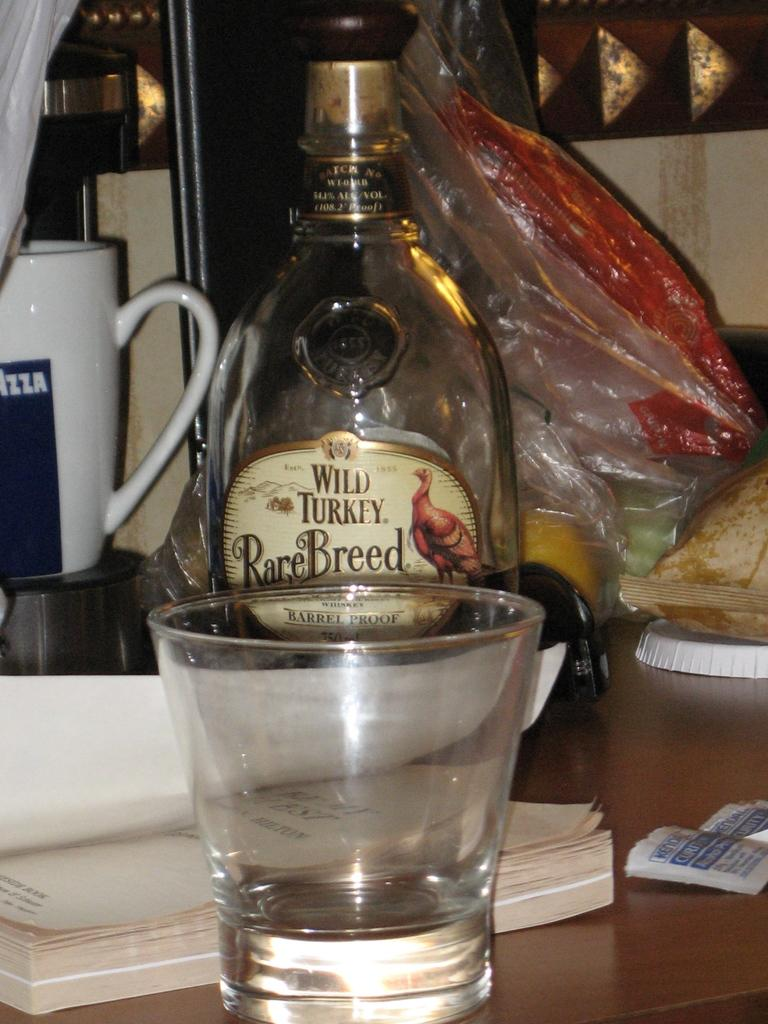What type of beverage container is in the image? There is a wine bottle in the image. What is another container visible in the image? There is a glass in the image. What non-beverage item can be seen in the image? There is a book in the image. What type of edible item is in the image? There is food in the image. What is the third container visible in the image? There is a cup in the image. Where are all these objects located? All objects are on a table. How many rings are stacked on the wine bottle in the image? There are no rings stacked on the wine bottle in the image. What type of wax is used to create the candle in the image? There is no candle present in the image, so it is not possible to determine the type of wax used. 